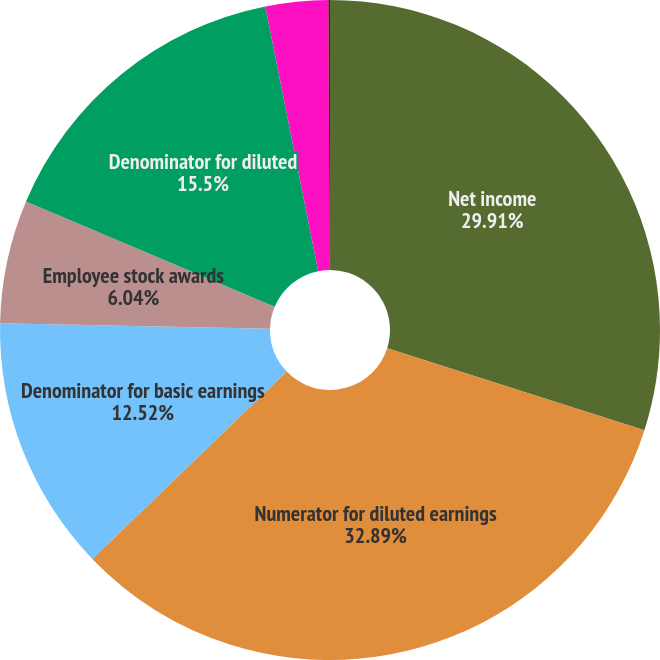Convert chart. <chart><loc_0><loc_0><loc_500><loc_500><pie_chart><fcel>Net income<fcel>Numerator for diluted earnings<fcel>Denominator for basic earnings<fcel>Employee stock awards<fcel>Denominator for diluted<fcel>Basic net income per common<fcel>Net income per common share<nl><fcel>29.91%<fcel>32.89%<fcel>12.52%<fcel>6.04%<fcel>15.5%<fcel>3.06%<fcel>0.08%<nl></chart> 